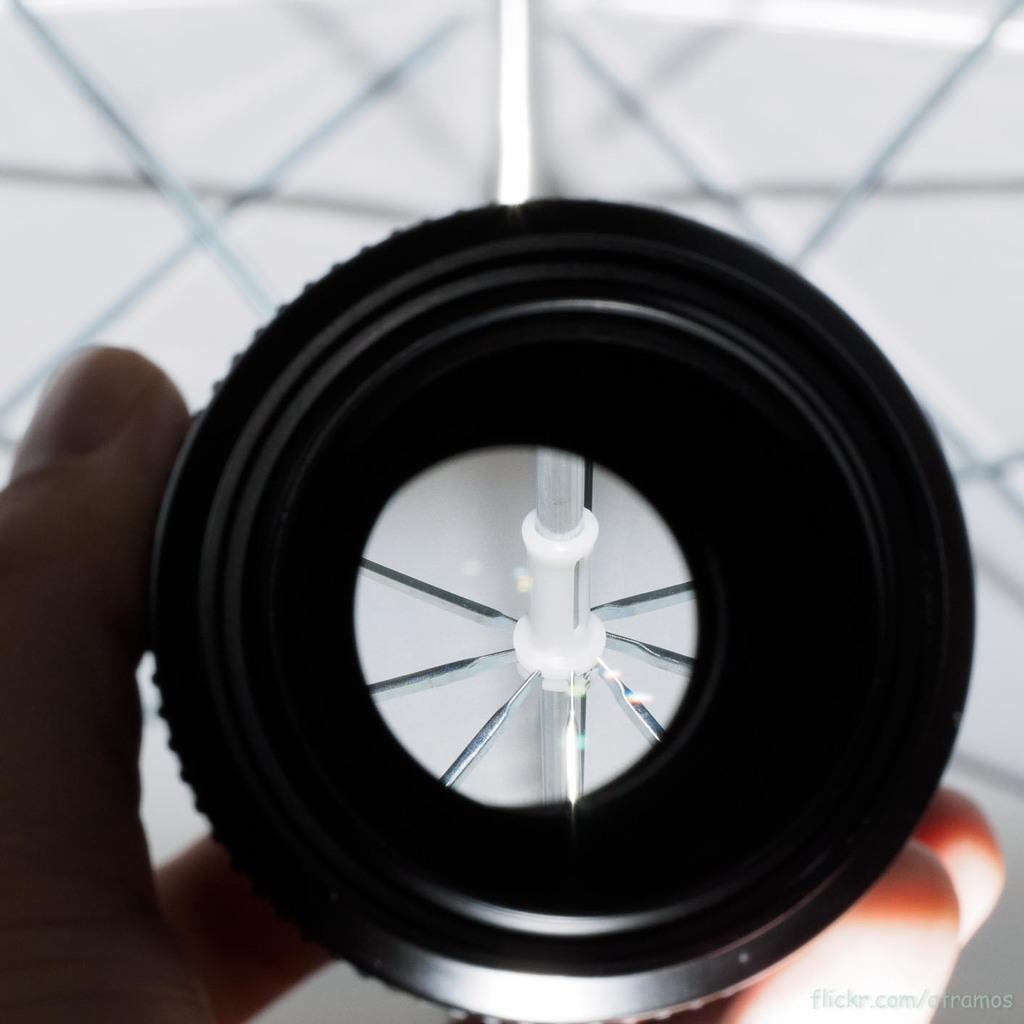What can be seen in the bottom left corner of the image? There is a hand in the bottom left corner of the image. What is the hand holding? There is an object in the hand. Can you describe the background of the image? The background of the image is blurred. How many bees can be seen buzzing around the object in the hand? There are no bees present in the image. What level of expertise does the person holding the object have, based on the image? The image does not provide any information about the person's level of expertise or experience. 